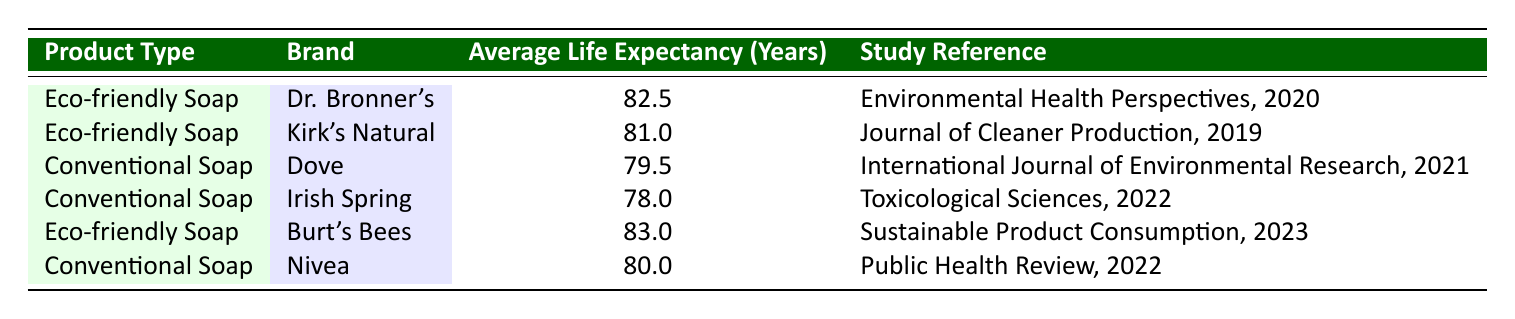What is the average life expectancy for eco-friendly soap users? To find the average life expectancy for eco-friendly soap users, we take the life expectancies for Dr. Bronner's (82.5 years), Kirk's Natural (81.0 years), and Burt's Bees (83.0 years). We sum these values: 82.5 + 81.0 + 83.0 = 246.5. There are 3 brands, so we divide by 3, giving us an average of 246.5 / 3 = 82.17 years.
Answer: 82.17 years What is the life expectancy of Dove soap? The life expectancy of Dove soap is listed directly in the table. It shows that Dove has an average life expectancy of 79.5 years.
Answer: 79.5 years Does Burt's Bees have a higher life expectancy than Irish Spring? Comparing the two, Burt's Bees has an average life expectancy of 83.0 years, while Irish Spring has 78.0 years. Since 83.0 is greater than 78.0, we conclude that Burt's Bees does have a higher life expectancy than Irish Spring.
Answer: Yes What is the difference in life expectancy between eco-friendly and conventional soaps? We first need to calculate the average life expectancy for eco-friendly and conventional soaps. The average for eco-friendly soaps is 82.17 years (calculated before), and for conventional soaps (Dove 79.5, Irish Spring 78.0, Nivea 80.0), we sum these values: 79.5 + 78.0 + 80.0 = 237.5, dividing by 3 gives an average of 79.17 years. The difference is then 82.17 - 79.17 = 3 years.
Answer: 3 years Which product type has the highest average life expectancy? By analyzing the table, we see that Burt's Bees (83.0 years) and Dr. Bronner's (82.5 years), both being eco-friendly soaps, are the highest; therefore, eco-friendly soap has the highest average life expectancy.
Answer: Eco-friendly soap Is the average life expectancy of Nivea higher than the average for all eco-friendly soaps? The average for eco-friendly soaps is approximately 82.17 years, while Nivea has a specific average life expectancy of 80.0 years. Since 80.0 is less than 82.17, this statement is false.
Answer: No 